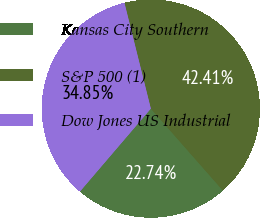Convert chart. <chart><loc_0><loc_0><loc_500><loc_500><pie_chart><fcel>Kansas City Southern<fcel>S&P 500 (1)<fcel>Dow Jones US Industrial<nl><fcel>22.74%<fcel>42.41%<fcel>34.85%<nl></chart> 